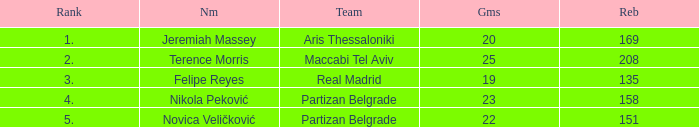What is the number of Games for the Maccabi Tel Aviv Team with less than 208 Rebounds? None. 